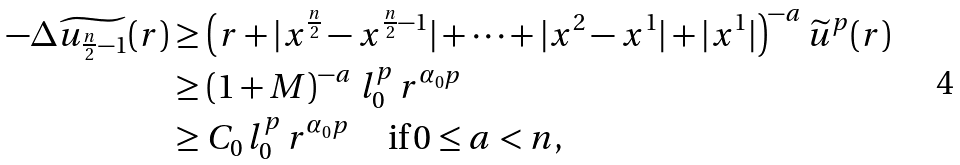<formula> <loc_0><loc_0><loc_500><loc_500>- \Delta \widetilde { u _ { \frac { n } { 2 } - 1 } } ( r ) & \geq \left ( r + | x ^ { \frac { n } { 2 } } - x ^ { \frac { n } { 2 } - 1 } | + \cdots + | x ^ { 2 } - x ^ { 1 } | + | x ^ { 1 } | \right ) ^ { - a } \widetilde { u } ^ { p } ( r ) \\ & \geq \left ( 1 + M \right ) ^ { - a } \, l _ { 0 } ^ { p } \, r ^ { \alpha _ { 0 } p } \\ & \geq C _ { 0 } \, l _ { 0 } ^ { p } \, r ^ { \alpha _ { 0 } p } \, \quad \text {if} \, 0 \leq a < n ,</formula> 